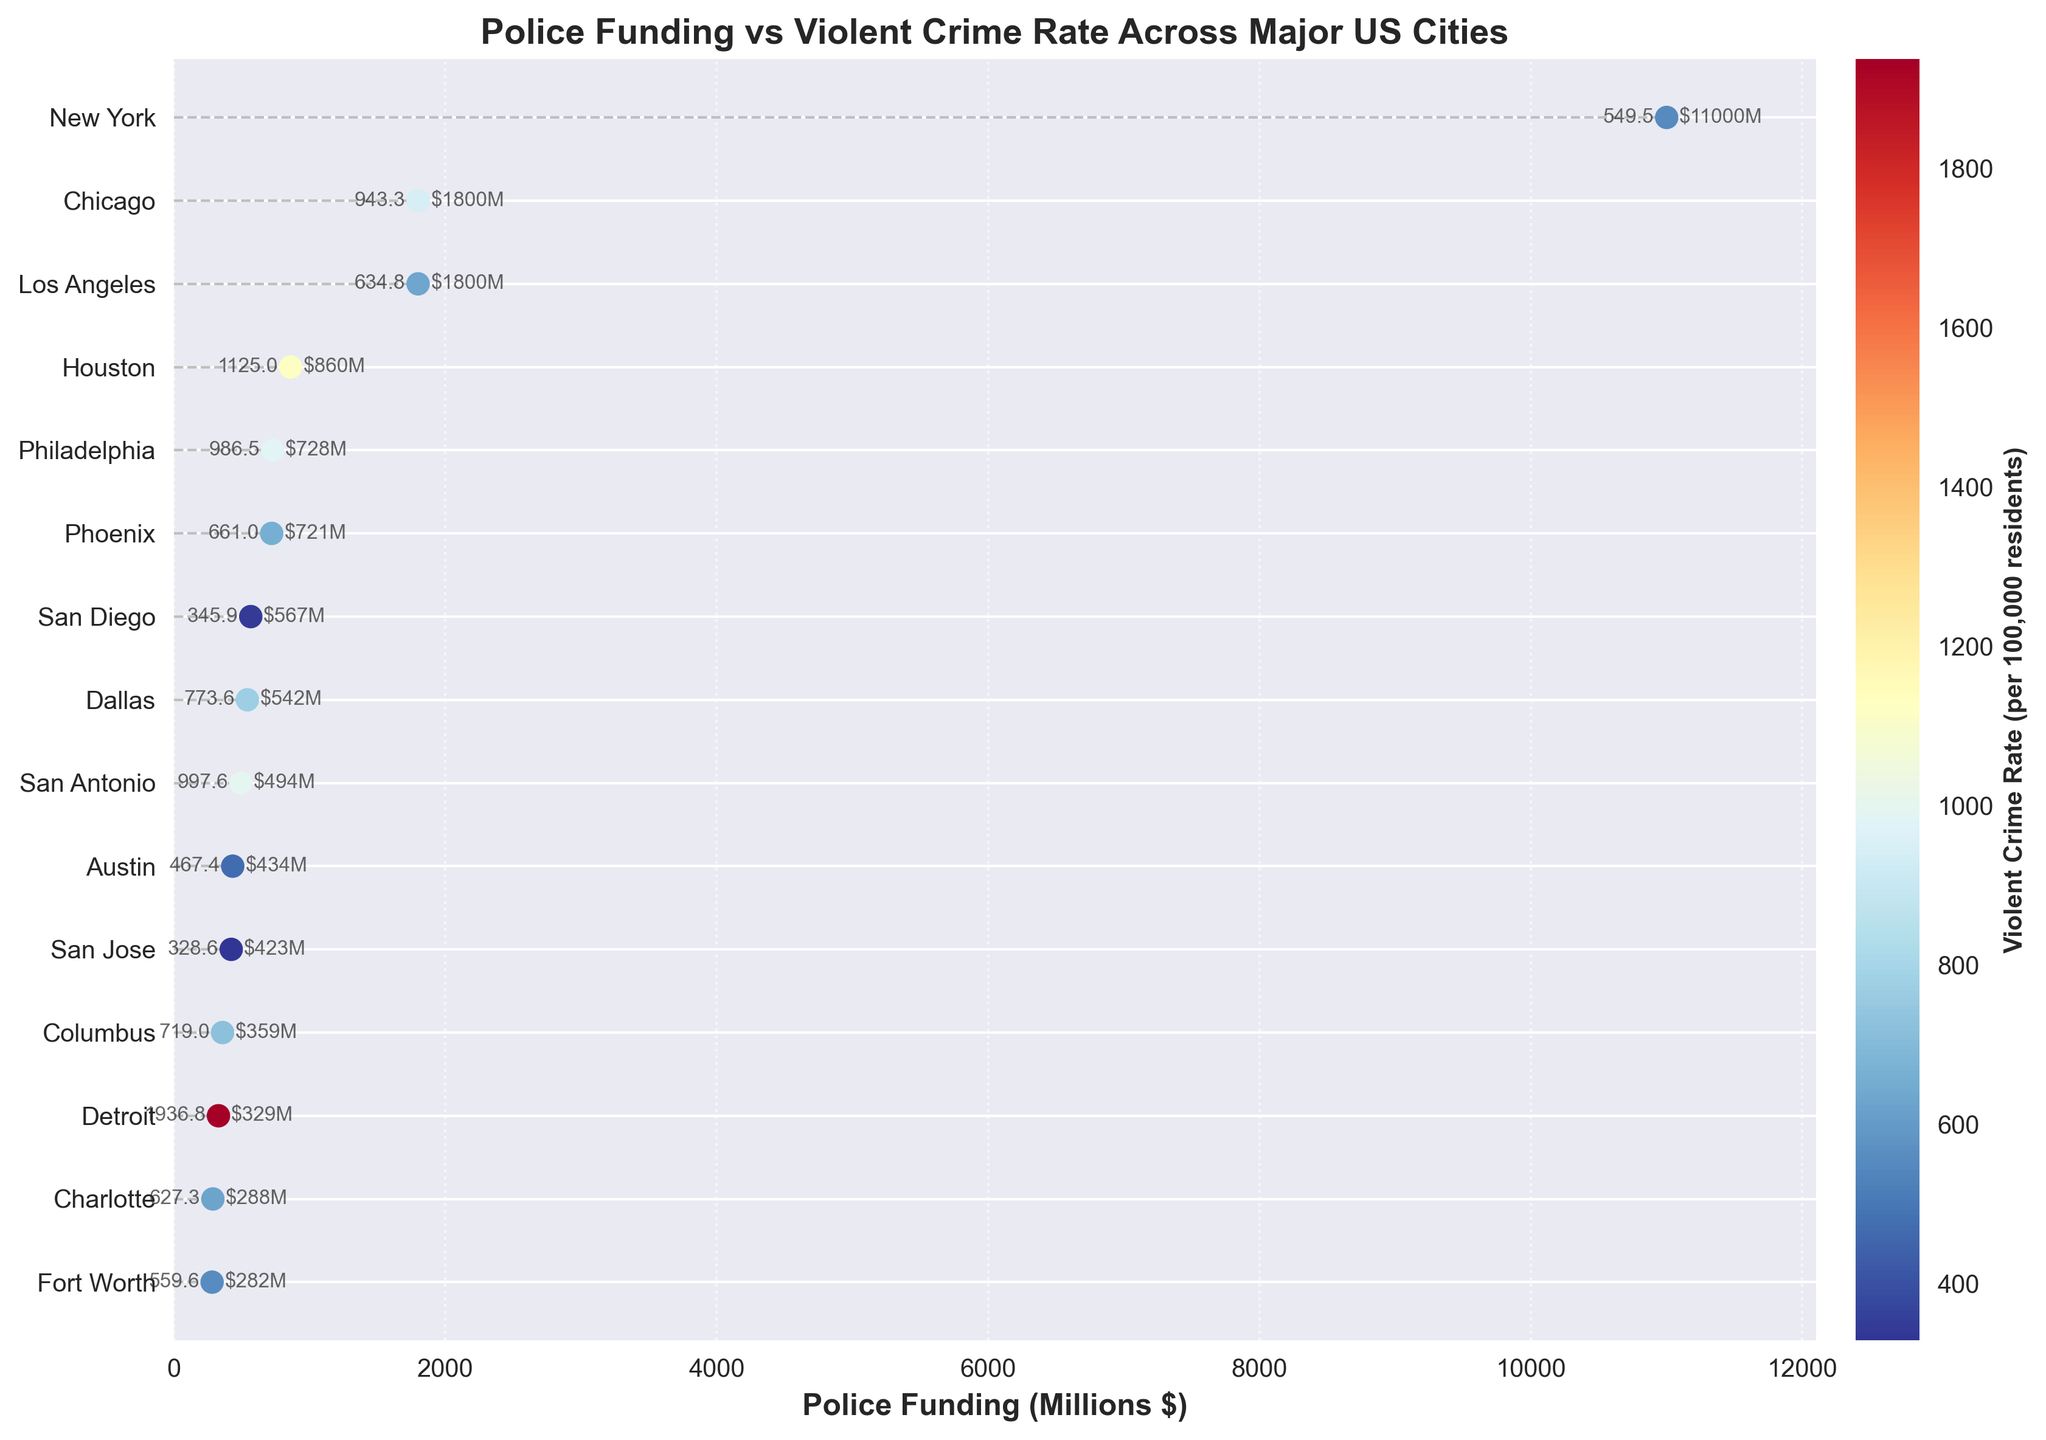What is the title of the figure? The title is located at the top of the plot and says "Police Funding vs Violent Crime Rate Across Major US Cities".
Answer: Police Funding vs Violent Crime Rate Across Major US Cities Which city has the highest police funding? By observing the scatter plot, the city with the highest value on the x-axis (Police Funding in Millions $) is New York.
Answer: New York What is the violent crime rate in Detroit? By locating Detroit on the y-axis and referring to the color legend, we see that the crime rate for Detroit is represented by a darker color, which is around 1936.8.
Answer: 1936.8 How many cities have a police funding greater than $1 billion? From the scatter plot, there are two cities with police funding above $1 billion: New York and Los Angeles.
Answer: 2 Which city has the lowest violent crime rate, and what is the rate? By noting the color and annotations representing violent crime rates, San Jose has the lightest color, indicating the lowest rate of 328.6.
Answer: San Jose, 328.6 Is there a clear correlation between police funding and violent crime rate? To determine the correlation, observe if there is a consistent pattern where higher funding results in lower violent crime rates. No definite trend can be easily observed, suggesting there isn't a clear correlation in the plot.
Answer: No Which city receives approximately the same police funding as Chicago, but has a lower violent crime rate? By comparing Chicago and other cities on the x-axis and observing their respective crime rates marked by colors, New York has similar funding ($1.8 billion) but a lower crime rate of 549.5 compared to 943.3.
Answer: New York What is the average police funding for all cities listed? Sum the police funding amounts for all cities and divide by the total number of cities: (11000+1800+1800+860+728+721+494+567+542+423+329+434+359+282+288) million dollars / 15 cities = 1,521.7 million dollars.
Answer: 1,521.7 million dollars Which city has the greatest difference between police funding and violent crime rate? Calculate the differences between funding levels and crime rates for each city. Detroit has the highest crime rate (1936.8) and relatively low funding (329 million dollars), giving it a significant difference.
Answer: Detroit 